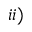<formula> <loc_0><loc_0><loc_500><loc_500>i i )</formula> 